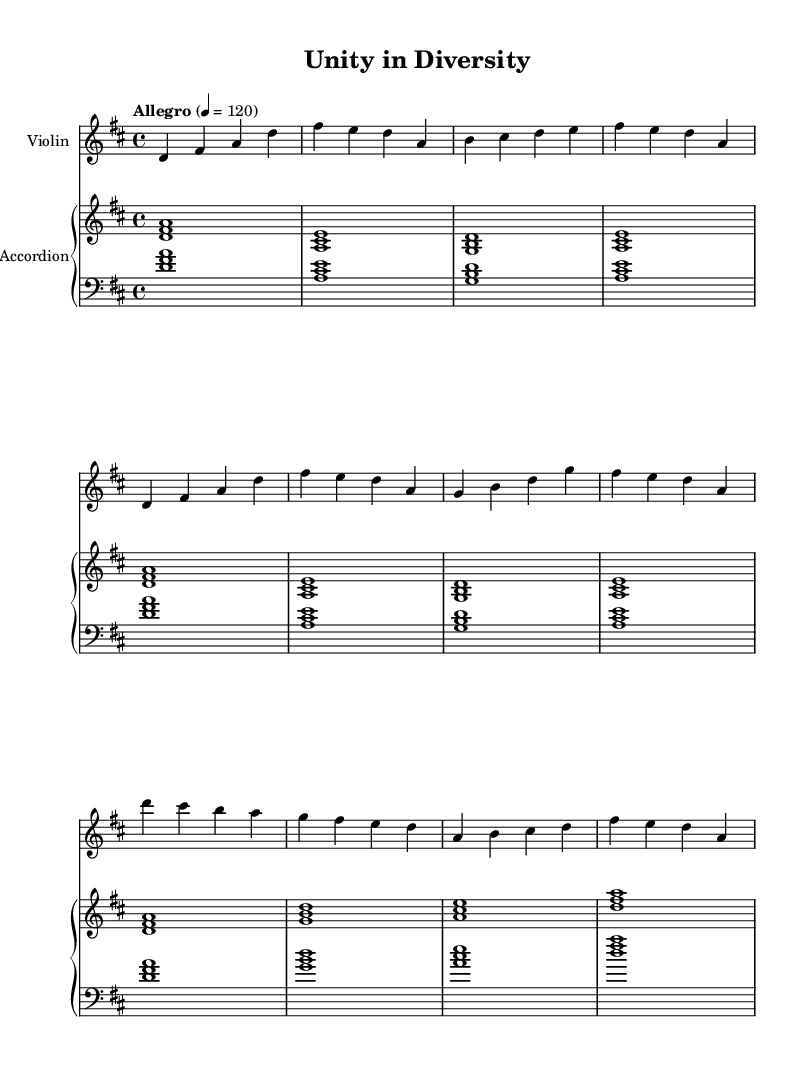What is the key signature of this music? The key signature indicated in the music is D major, which has two sharps (F# and C#). This is visible in the key signature at the beginning of the score.
Answer: D major What is the time signature of the piece? The time signature shown at the beginning of the music is 4/4, indicating four beats per measure, with each beat represented by a quarter note.
Answer: 4/4 What is the tempo marking for this piece? The tempo marking displayed is "Allegro," which typically indicates a fast and lively pace, alongside a metronome marking of 120 beats per minute.
Answer: Allegro How many measures does the intro section contain? Counting the measures in the intro section (marked separately), there are four distinct measures that outline the introductory part of the piece.
Answer: Four measures What instruments are included in the score? The score shows two instruments: Violin, indicated as the upper staff, and Accordion, shown as a PianoStaff with a right-hand staff and left-hand staff.
Answer: Violin and Accordion What is the first note played by the violin in the intro? The first note played by the violin in the introductory section is D, which can be observed in the first measure of the violin music.
Answer: D How does the chord progression in the accordion compare to traditional European folk music? The accordion's chord progression features triads like D, A, and G, commonly seen in European folk music, which usually emphasizes simple, diatonic harmonies that support a joyful and communal feel, reflecting cultural unity.
Answer: Simple triads 